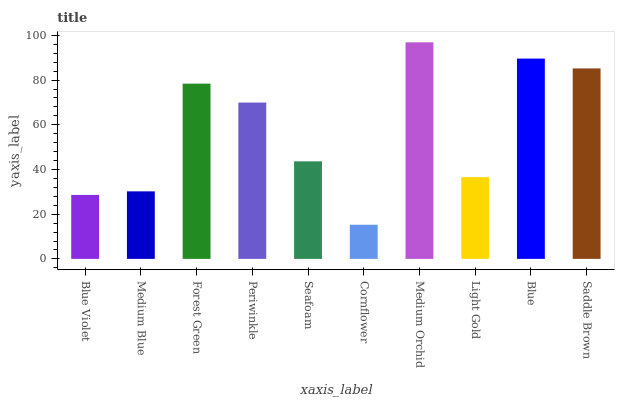Is Cornflower the minimum?
Answer yes or no. Yes. Is Medium Orchid the maximum?
Answer yes or no. Yes. Is Medium Blue the minimum?
Answer yes or no. No. Is Medium Blue the maximum?
Answer yes or no. No. Is Medium Blue greater than Blue Violet?
Answer yes or no. Yes. Is Blue Violet less than Medium Blue?
Answer yes or no. Yes. Is Blue Violet greater than Medium Blue?
Answer yes or no. No. Is Medium Blue less than Blue Violet?
Answer yes or no. No. Is Periwinkle the high median?
Answer yes or no. Yes. Is Seafoam the low median?
Answer yes or no. Yes. Is Blue Violet the high median?
Answer yes or no. No. Is Blue the low median?
Answer yes or no. No. 